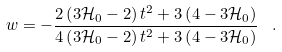Convert formula to latex. <formula><loc_0><loc_0><loc_500><loc_500>w = - \frac { 2 \left ( 3 { \mathcal { H } } _ { 0 } - 2 \right ) t ^ { 2 } + 3 \left ( 4 - 3 { \mathcal { H } } _ { 0 } \right ) } { 4 \left ( 3 { \mathcal { H } } _ { 0 } - 2 \right ) t ^ { 2 } + 3 \left ( 4 - 3 { \mathcal { H } } _ { 0 } \right ) } \text { } \, .</formula> 